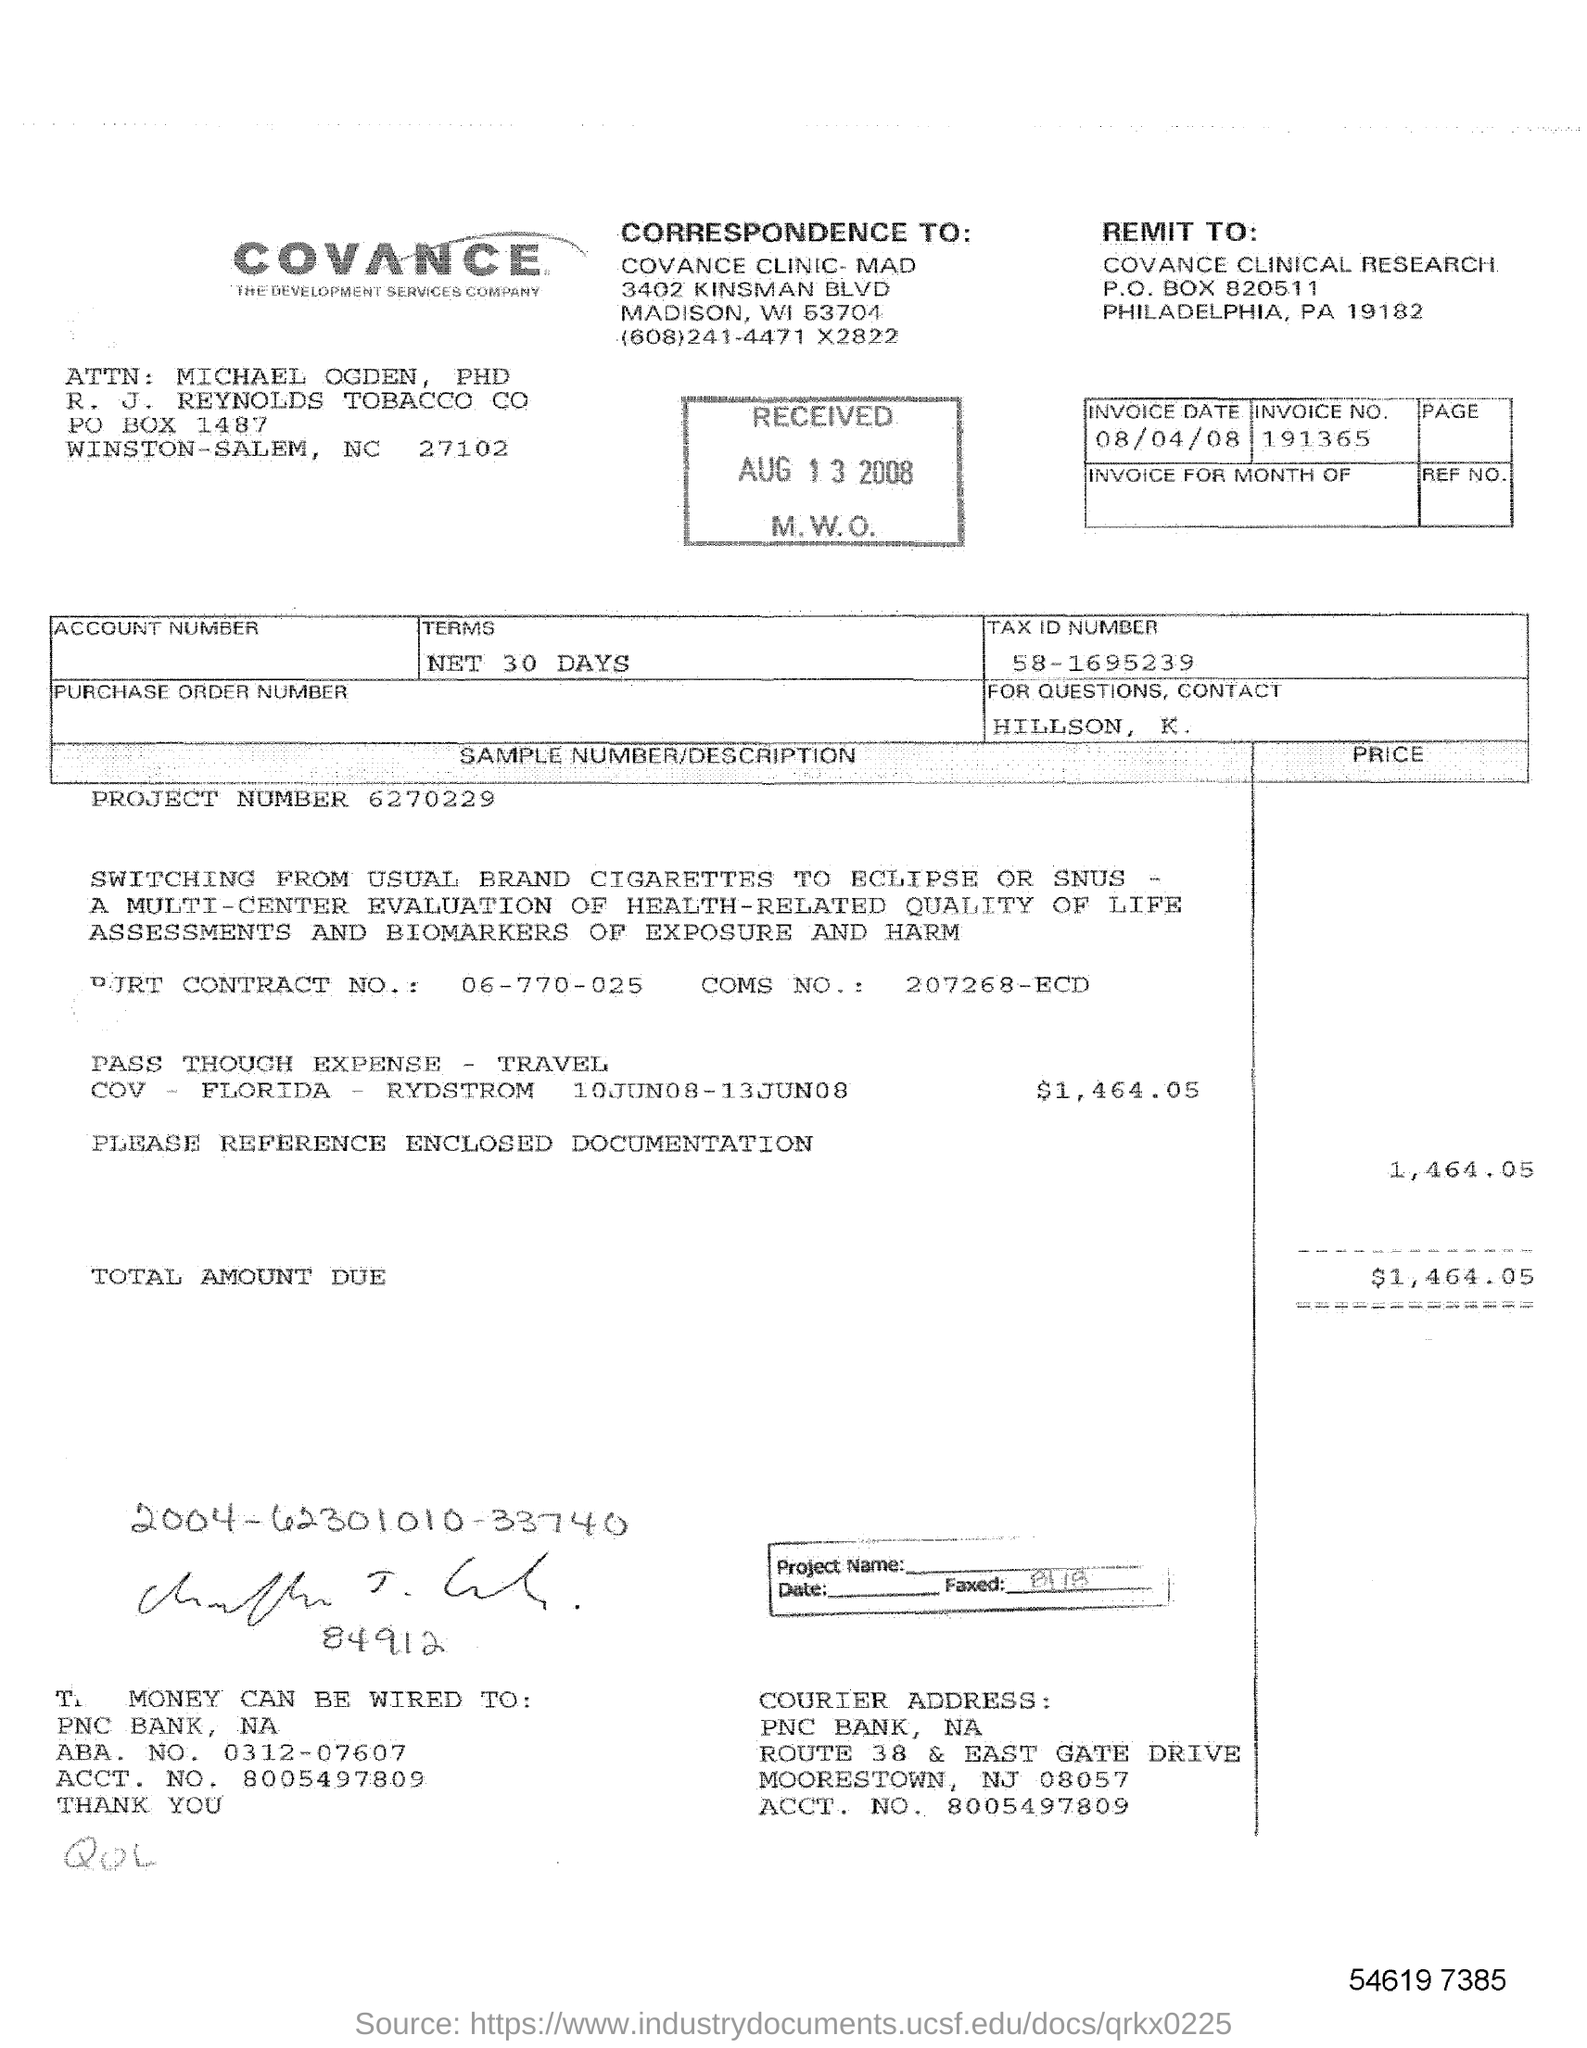Identify some key points in this picture. The invoice number is 191365... If there are any queries, please contact Hillson, K... The project number is 6270229. The total travel expense is $1,464.05. It is possible to wire money to the PNC bank. 